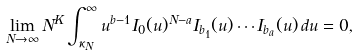<formula> <loc_0><loc_0><loc_500><loc_500>\lim _ { N \to \infty } N ^ { K } \int _ { \kappa _ { N } } ^ { \infty } u ^ { b - 1 } I _ { 0 } ( u ) ^ { N - a } I _ { b _ { 1 } } ( u ) \cdots I _ { b _ { a } } ( u ) \, d u = 0 ,</formula> 